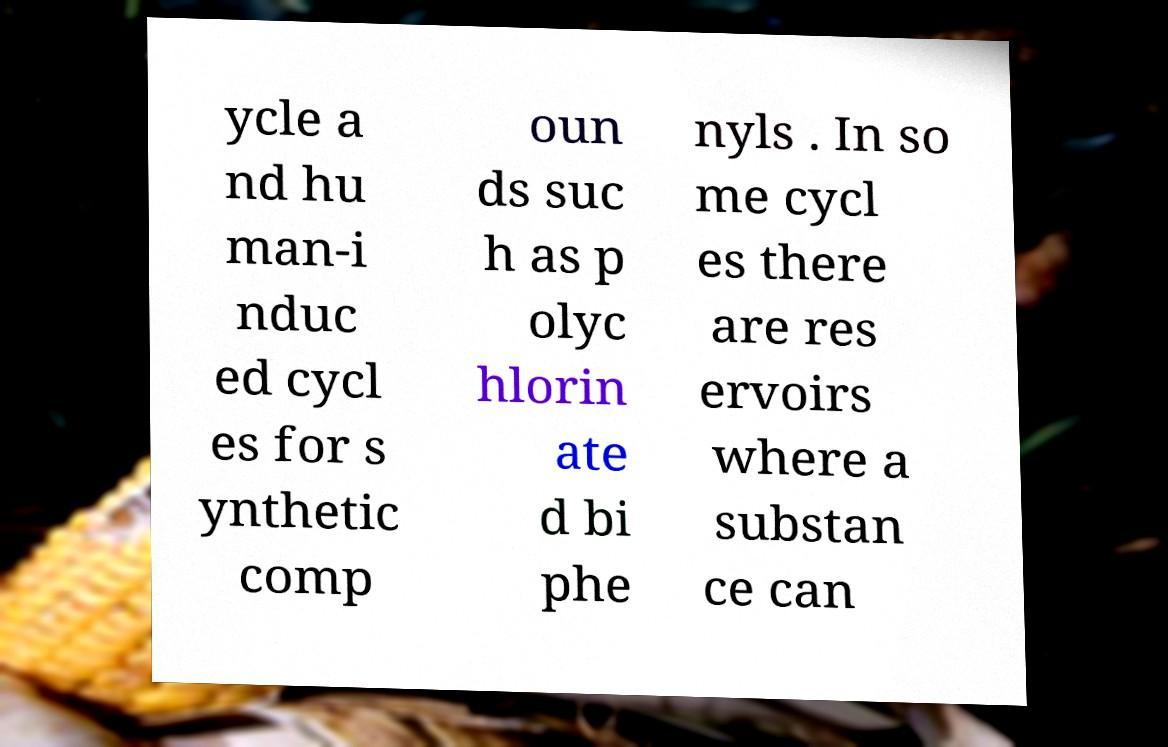Please identify and transcribe the text found in this image. ycle a nd hu man-i nduc ed cycl es for s ynthetic comp oun ds suc h as p olyc hlorin ate d bi phe nyls . In so me cycl es there are res ervoirs where a substan ce can 